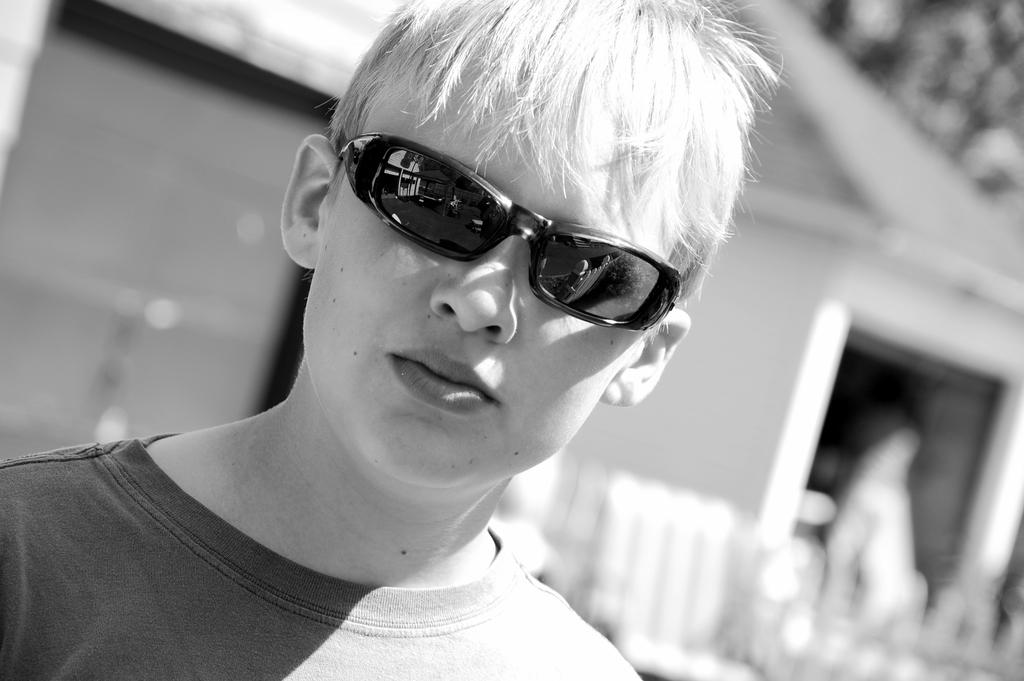What is the color scheme of the image? The image is black and white. Who is present in the image? There is a man in the image. What is the man wearing that is noticeable? The man is wearing black color spectacles. What can be seen in the background of the image? There is a building in the background of the image. What type of thrill can be seen in the image? There is no thrill present in the image; it features a man wearing black color spectacles with a building in the background. How many balloons are visible in the image? There are no balloons present in the image. 